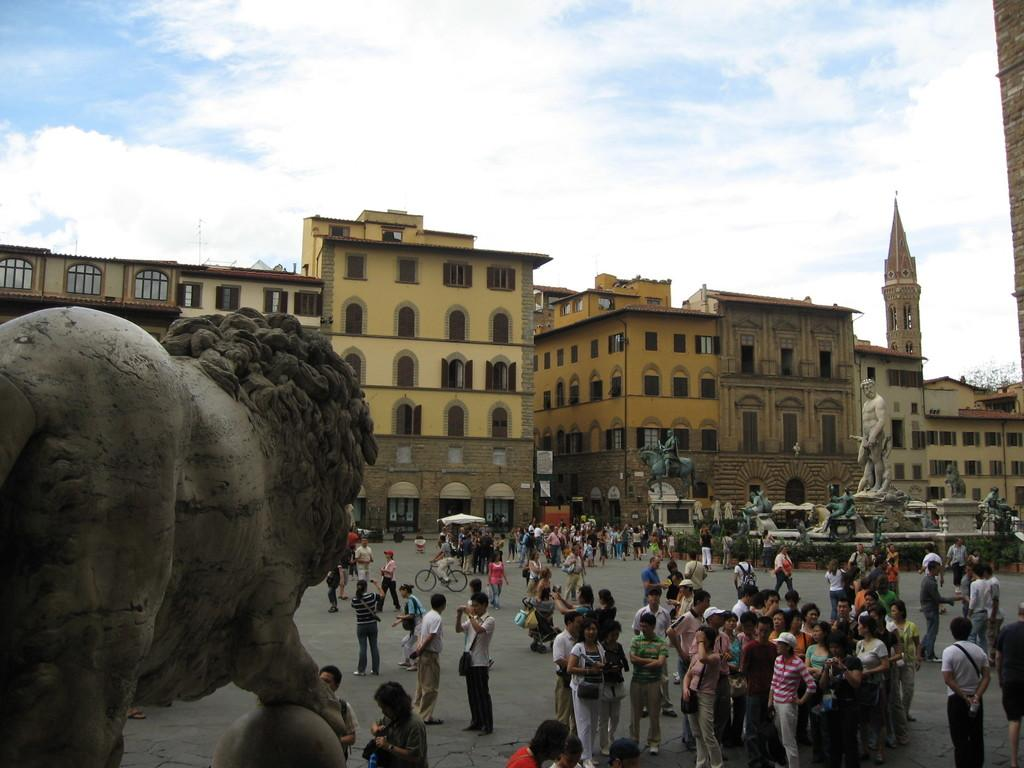What is located on the left side of the image? There is a sculpture on the left side of the image. Can you describe the people in the image? People are present in the image, and one person is riding a bicycle. Are there any other sculptures visible in the image? Yes, there are other sculptures visible in the image. What can be seen in the background of the image? There are buildings in the background of the image. What type of peace symbol can be seen in the image? There is no peace symbol present in the image. Are there any police officers visible in the image? There is no mention of police officers in the provided facts, so we cannot determine if they are present in the image. What message of love is being conveyed by the sculptures in the image? The provided facts do not mention any specific message of love being conveyed by the sculptures in the image. 